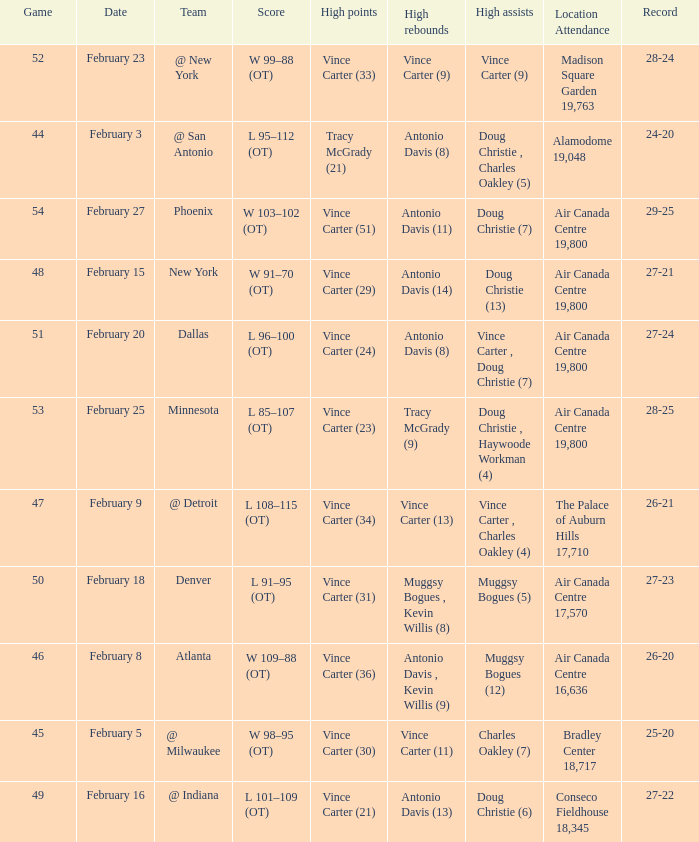Who was the opposing team for game 53? Minnesota. 